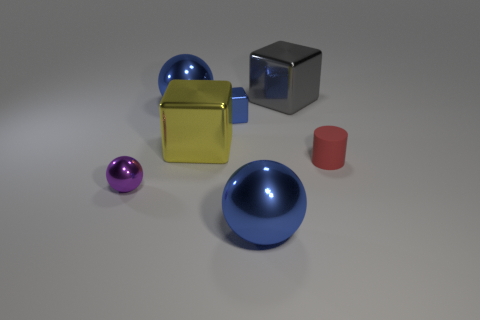What is the size of the gray cube?
Your answer should be compact. Large. Is there any other thing that is the same size as the red matte thing?
Offer a terse response. Yes. There is a large object in front of the yellow metal block; does it have the same shape as the big blue object that is behind the small sphere?
Provide a succinct answer. Yes. What is the shape of the blue metal thing that is the same size as the red matte thing?
Your response must be concise. Cube. Are there an equal number of metal objects that are in front of the gray thing and big yellow cubes in front of the small ball?
Offer a terse response. No. Is there any other thing that has the same shape as the big yellow metal object?
Ensure brevity in your answer.  Yes. Does the big blue thing in front of the tiny red object have the same material as the yellow block?
Give a very brief answer. Yes. There is a ball that is the same size as the rubber thing; what is it made of?
Ensure brevity in your answer.  Metal. What number of other objects are the same material as the tiny sphere?
Your response must be concise. 5. Does the yellow thing have the same size as the blue ball in front of the small red matte cylinder?
Ensure brevity in your answer.  Yes. 